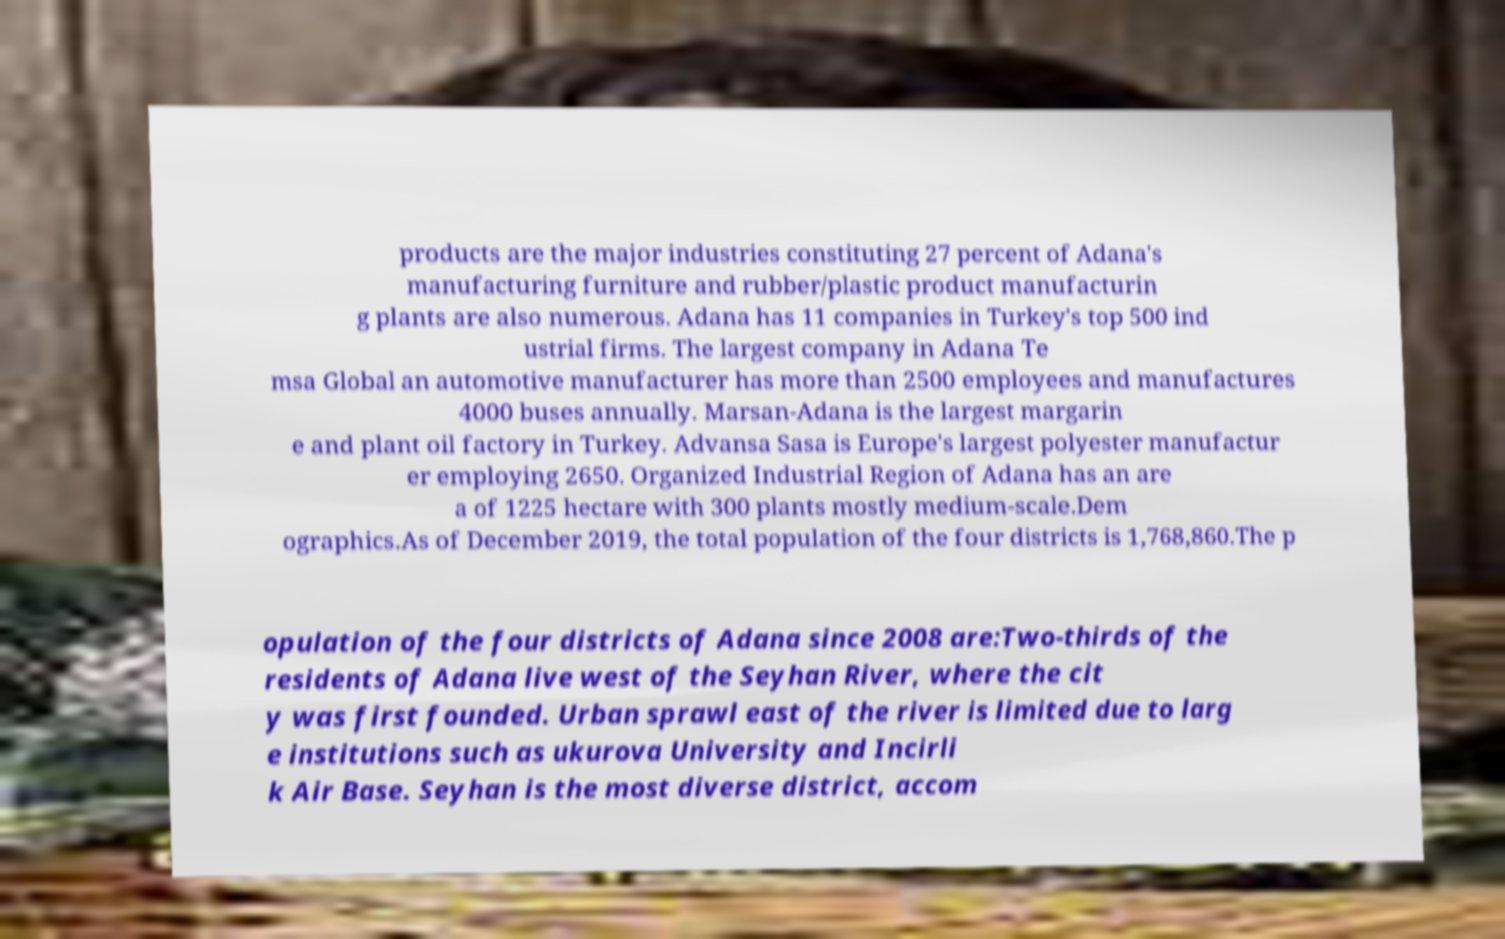There's text embedded in this image that I need extracted. Can you transcribe it verbatim? products are the major industries constituting 27 percent of Adana's manufacturing furniture and rubber/plastic product manufacturin g plants are also numerous. Adana has 11 companies in Turkey's top 500 ind ustrial firms. The largest company in Adana Te msa Global an automotive manufacturer has more than 2500 employees and manufactures 4000 buses annually. Marsan-Adana is the largest margarin e and plant oil factory in Turkey. Advansa Sasa is Europe's largest polyester manufactur er employing 2650. Organized Industrial Region of Adana has an are a of 1225 hectare with 300 plants mostly medium-scale.Dem ographics.As of December 2019, the total population of the four districts is 1,768,860.The p opulation of the four districts of Adana since 2008 are:Two-thirds of the residents of Adana live west of the Seyhan River, where the cit y was first founded. Urban sprawl east of the river is limited due to larg e institutions such as ukurova University and Incirli k Air Base. Seyhan is the most diverse district, accom 